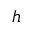Convert formula to latex. <formula><loc_0><loc_0><loc_500><loc_500>h</formula> 